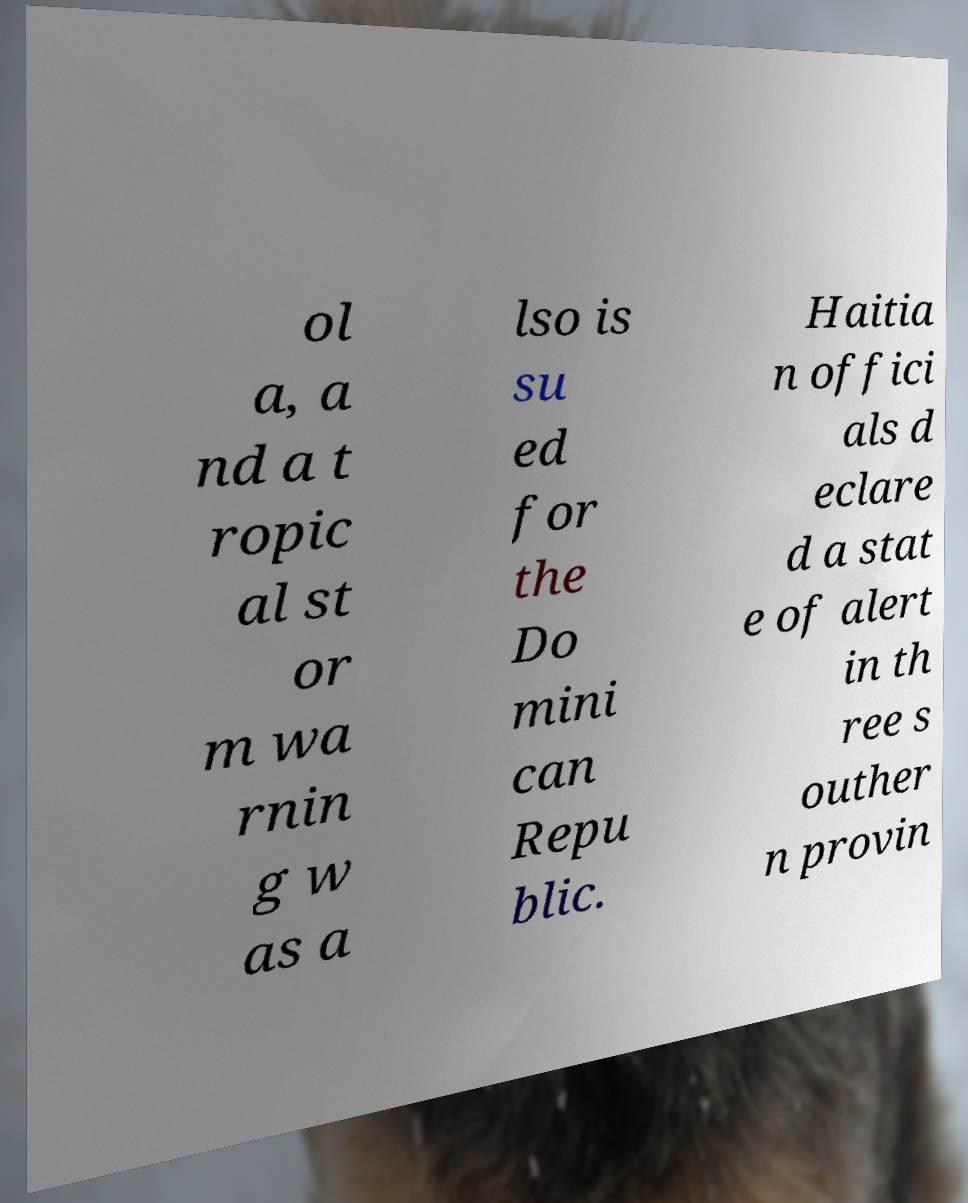There's text embedded in this image that I need extracted. Can you transcribe it verbatim? ol a, a nd a t ropic al st or m wa rnin g w as a lso is su ed for the Do mini can Repu blic. Haitia n offici als d eclare d a stat e of alert in th ree s outher n provin 